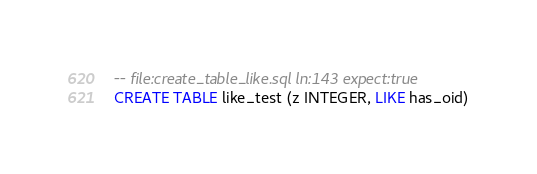<code> <loc_0><loc_0><loc_500><loc_500><_SQL_>-- file:create_table_like.sql ln:143 expect:true
CREATE TABLE like_test (z INTEGER, LIKE has_oid)
</code> 